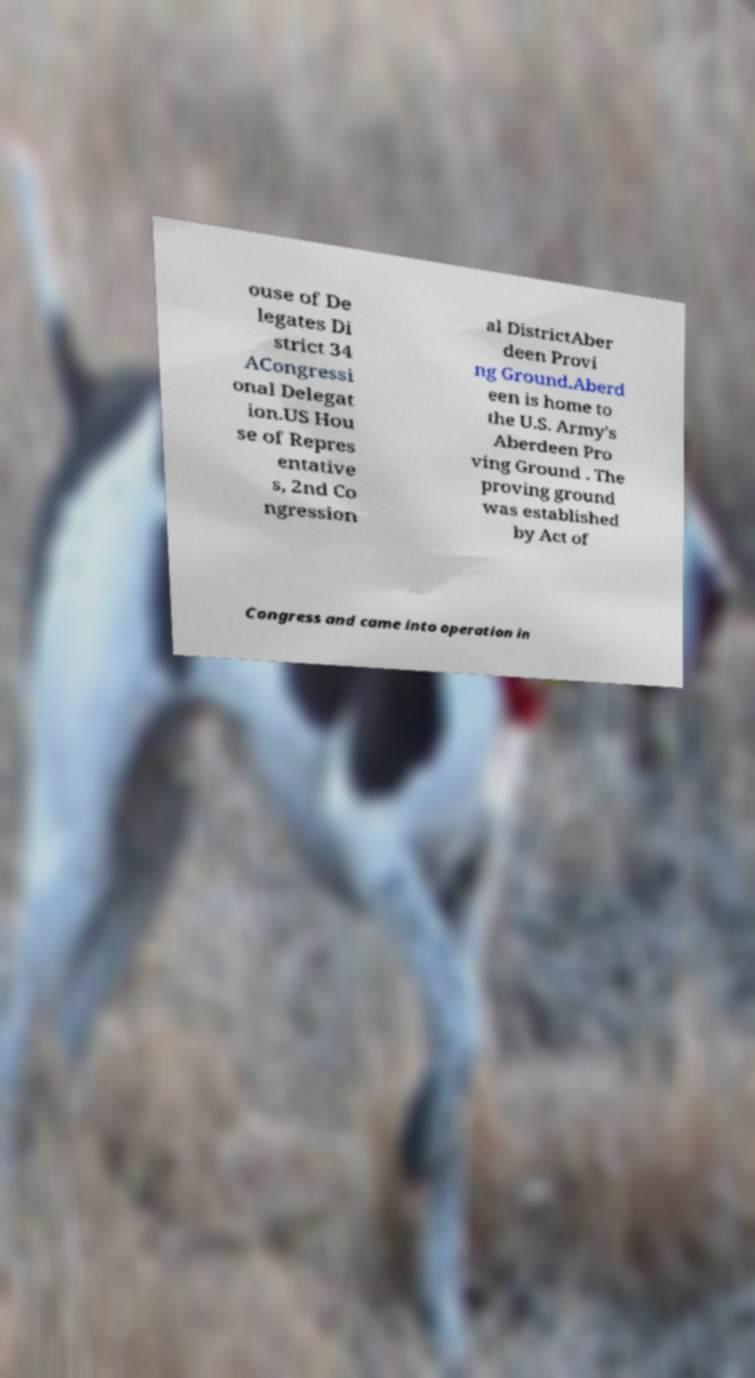What messages or text are displayed in this image? I need them in a readable, typed format. ouse of De legates Di strict 34 ACongressi onal Delegat ion.US Hou se of Repres entative s, 2nd Co ngression al DistrictAber deen Provi ng Ground.Aberd een is home to the U.S. Army's Aberdeen Pro ving Ground . The proving ground was established by Act of Congress and came into operation in 